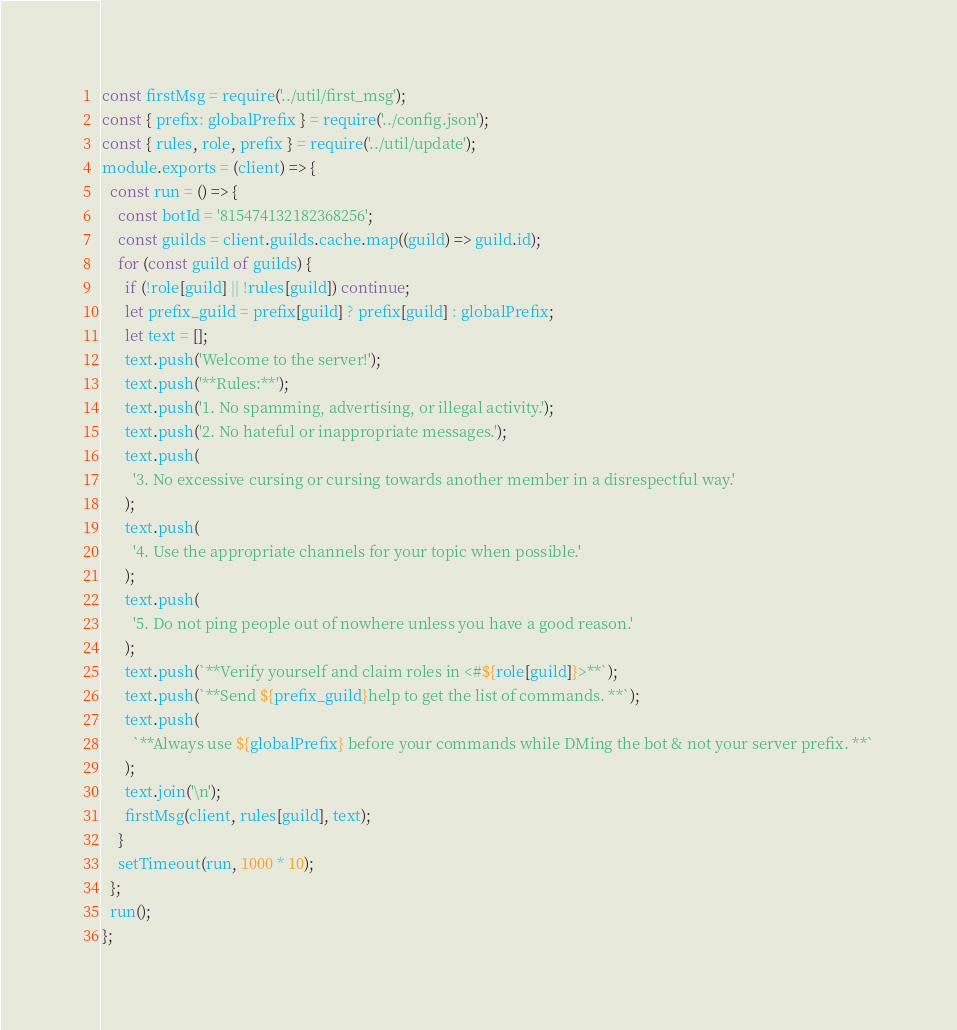Convert code to text. <code><loc_0><loc_0><loc_500><loc_500><_JavaScript_>const firstMsg = require('../util/first_msg');
const { prefix: globalPrefix } = require('../config.json');
const { rules, role, prefix } = require('../util/update');
module.exports = (client) => {
  const run = () => {
    const botId = '815474132182368256';
    const guilds = client.guilds.cache.map((guild) => guild.id);
    for (const guild of guilds) {
      if (!role[guild] || !rules[guild]) continue;
      let prefix_guild = prefix[guild] ? prefix[guild] : globalPrefix;
      let text = [];
      text.push('Welcome to the server!');
      text.push('**Rules:**');
      text.push('1. No spamming, advertising, or illegal activity.');
      text.push('2. No hateful or inappropriate messages.');
      text.push(
        '3. No excessive cursing or cursing towards another member in a disrespectful way.'
      );
      text.push(
        '4. Use the appropriate channels for your topic when possible.'
      );
      text.push(
        '5. Do not ping people out of nowhere unless you have a good reason.'
      );
      text.push(`**Verify yourself and claim roles in <#${role[guild]}>**`);
      text.push(`**Send ${prefix_guild}help to get the list of commands. **`);
      text.push(
        `**Always use ${globalPrefix} before your commands while DMing the bot & not your server prefix. **`
      );
      text.join('\n');
      firstMsg(client, rules[guild], text);
    }
    setTimeout(run, 1000 * 10);
  };
  run();
};
</code> 